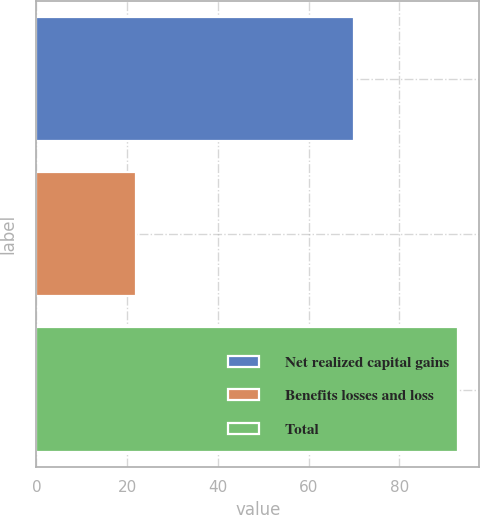Convert chart to OTSL. <chart><loc_0><loc_0><loc_500><loc_500><bar_chart><fcel>Net realized capital gains<fcel>Benefits losses and loss<fcel>Total<nl><fcel>70<fcel>22<fcel>93<nl></chart> 